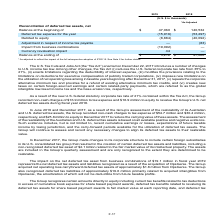According to Atlassian Plc's financial document, When was the U.S. Tax Cuts and Jobs Act enacted? According to the financial document, December 22, 2017. The relevant text states: "Tax Cuts and Jobs Act (the “Tax Act”) enacted on December 22, 2017 introduces a number of changes..." Also, What is the new U.S. federal corporate tax rate after the Tax Act was enacted? According to the financial document, 21%. The relevant text states: "es the U.S. federal corporate tax rate from 35% to 21%, (ii) enacts limitations regarding the deductibility of interest expense, (iii) modifies the provis..." Also, What is the  Balance at the beginning of 2019? According to the financial document, $47,060 (in thousands). The relevant text states: "Balance at the beginning of $ 47,060 $ 140,532..." Also, can you calculate: What is the change in the ending balance between fiscal years 2018 and 2019? Based on the calculation: 3,212-47,060, the result is -43848 (in thousands). This is based on the information: "Balance at the beginning of $ 47,060 $ 140,532 Balance at the ending of $ 3,212 $ 47,060..." The key data points involved are: 3,212, 47,060. Also, can you calculate: What is the average deferred tax expense for fiscal years 2018 and 2019? To answer this question, I need to perform calculations using the financial data. The calculation is: -(15,916+53,297)/2, which equals -34606.5 (in thousands). This is based on the information: "Deferred tax expense for the year (15,916) (53,297) Deferred tax expense for the year (15,916) (53,297)..." The key data points involved are: 15,916, 53,297. Also, can you calculate: What is the percentage change of deferred tax expenses between fiscal year 2018 to 2019? To answer this question, I need to perform calculations using the financial data. The calculation is: (-15,916-(-53,297))/(-53,297), which equals -70.14 (percentage). This is based on the information: "Deferred tax expense for the year (15,916) (53,297) Deferred tax expense for the year (15,916) (53,297)..." The key data points involved are: 15,916, 53,297. 